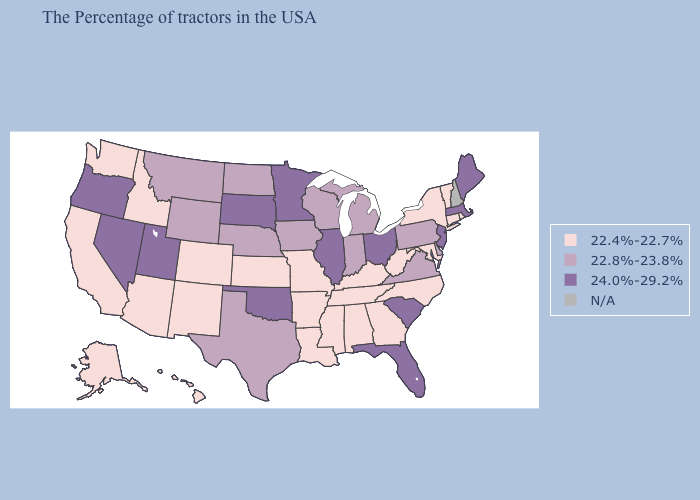What is the highest value in the Northeast ?
Short answer required. 24.0%-29.2%. What is the lowest value in the MidWest?
Be succinct. 22.4%-22.7%. Among the states that border Minnesota , which have the highest value?
Give a very brief answer. South Dakota. Among the states that border Mississippi , which have the highest value?
Concise answer only. Alabama, Tennessee, Louisiana, Arkansas. Does the first symbol in the legend represent the smallest category?
Quick response, please. Yes. Does the map have missing data?
Concise answer only. Yes. Name the states that have a value in the range N/A?
Be succinct. New Hampshire. Is the legend a continuous bar?
Keep it brief. No. How many symbols are there in the legend?
Concise answer only. 4. Among the states that border Arkansas , does Oklahoma have the highest value?
Quick response, please. Yes. Which states have the highest value in the USA?
Be succinct. Maine, Massachusetts, New Jersey, South Carolina, Ohio, Florida, Illinois, Minnesota, Oklahoma, South Dakota, Utah, Nevada, Oregon. Among the states that border Minnesota , does North Dakota have the lowest value?
Concise answer only. Yes. Name the states that have a value in the range 22.4%-22.7%?
Answer briefly. Rhode Island, Vermont, Connecticut, New York, Maryland, North Carolina, West Virginia, Georgia, Kentucky, Alabama, Tennessee, Mississippi, Louisiana, Missouri, Arkansas, Kansas, Colorado, New Mexico, Arizona, Idaho, California, Washington, Alaska, Hawaii. 